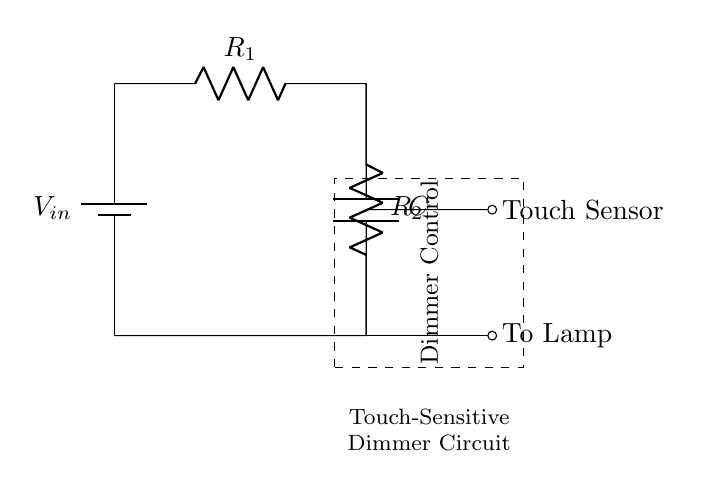What is the input voltage to the circuit? The input voltage is represented by the label V_in at the battery, which serves as the source for the circuit.
Answer: V_in What are the resistors in the circuit? The resistors are labeled as R1 and R2; they are distinct components that influence the division of voltage in the circuit.
Answer: R1, R2 What is the function of the capacitor? The capacitor, labeled C, helps smooth the output voltage and influences the timing characteristics of the dimmer switch control.
Answer: Smoothing How is the touch sensor connected in the circuit? The touch sensor is connected at the junction between R1 and R2, enabling it to sense changes in voltage to control the dimming.
Answer: Between R1 and R2 What happens when the touch sensor is activated? When activated, the touch sensor sends a signal that alters the voltage across the capacitor, affecting the brightness of the lamp connected to the circuit.
Answer: Changes brightness What is the function of the voltage divider in this circuit? The voltage divider created by R1 and R2 sets the output voltage level that determines how much power the lamp receives, thus dimming it.
Answer: Sets output voltage How does the capacitor influence the dimming effect? The capacitor stores charge and discharges it slowly, which creates a gradual change in brightness rather than an abrupt change when the touch sensor is activated.
Answer: Gradual change 